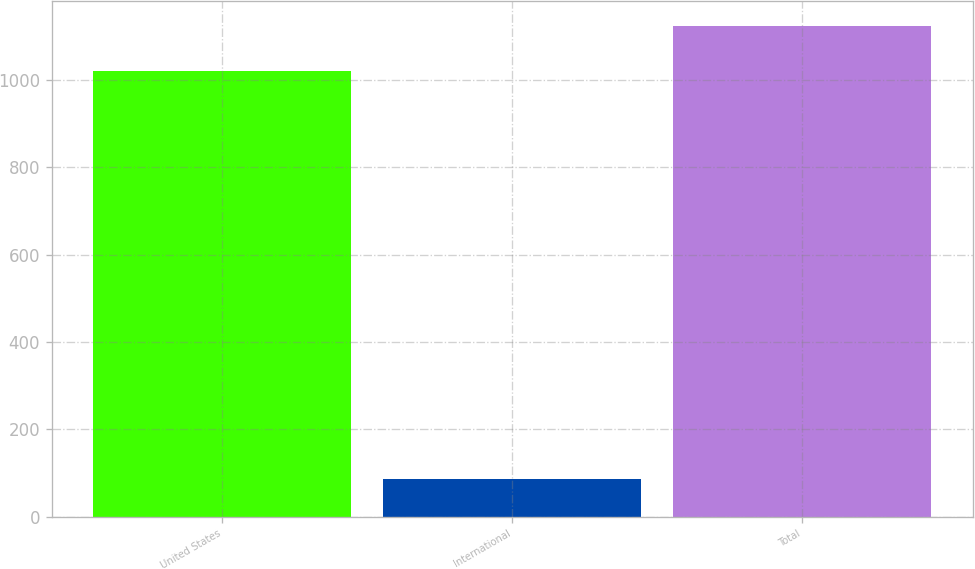Convert chart. <chart><loc_0><loc_0><loc_500><loc_500><bar_chart><fcel>United States<fcel>International<fcel>Total<nl><fcel>1021.4<fcel>87.4<fcel>1123.54<nl></chart> 